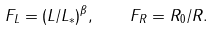<formula> <loc_0><loc_0><loc_500><loc_500>F _ { L } = ( L / L _ { \ast } ) ^ { \beta } , \quad F _ { R } = R _ { 0 } / R .</formula> 